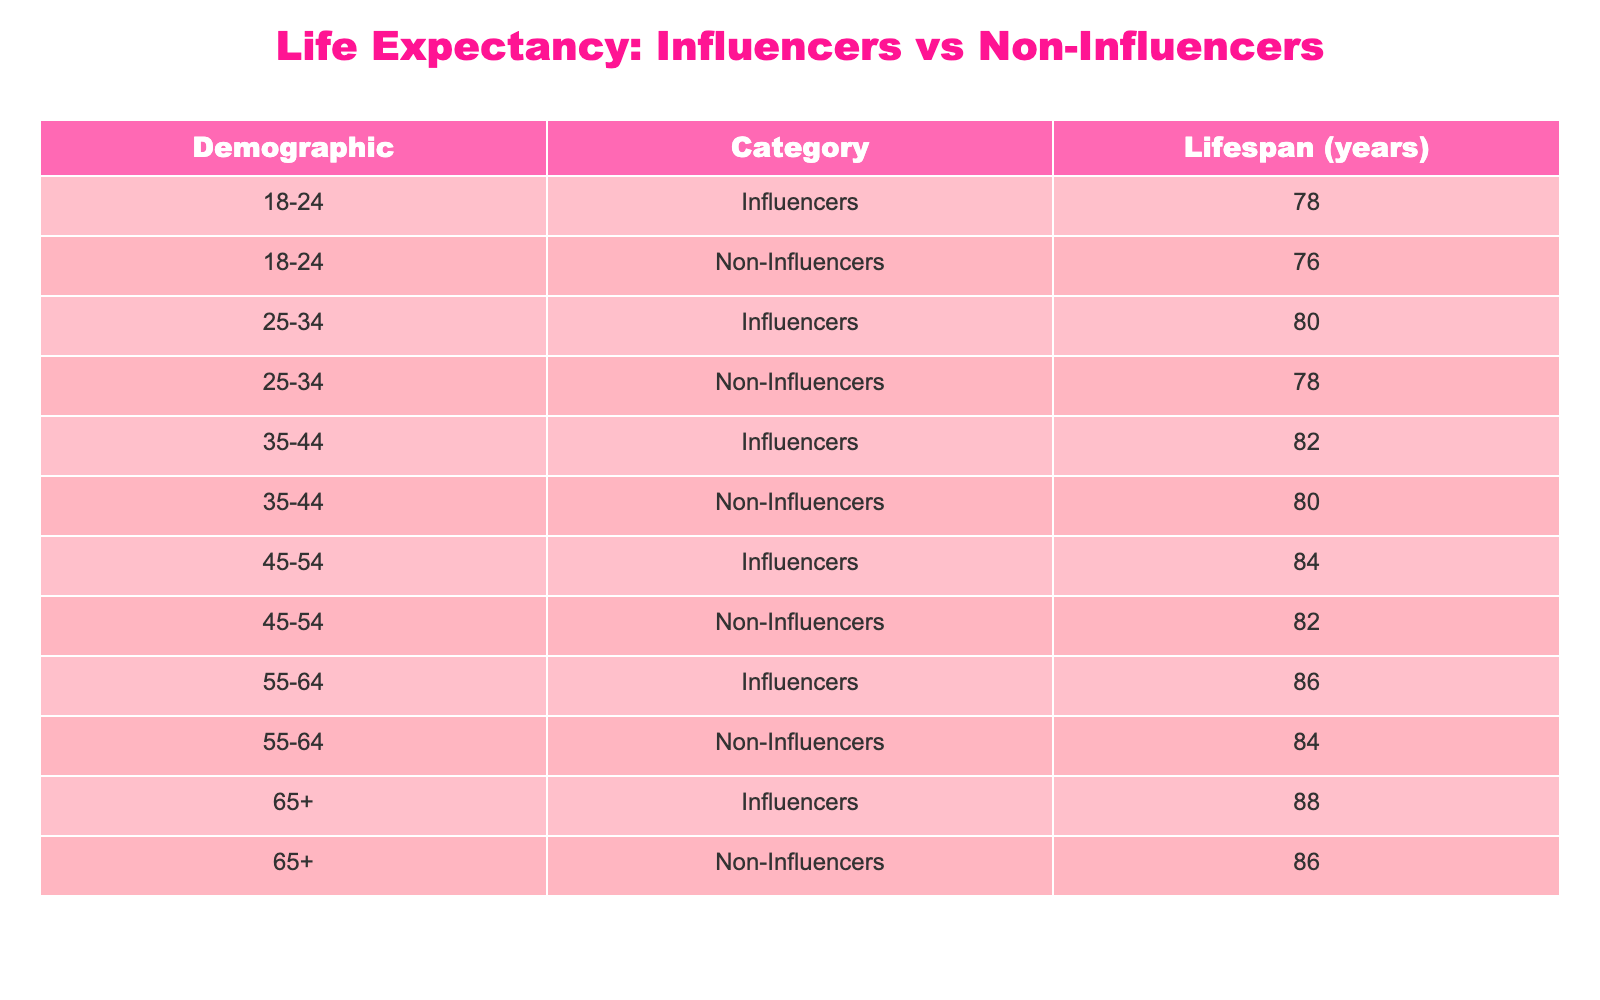What is the life expectancy of influencers aged 55-64? According to the table, the lifespan for influencers in the 55-64 demographic is listed explicitly. You can find the corresponding value from the row under "55-64" and "Influencers."
Answer: 86 What is the difference in life expectancy between non-influencers aged 25-34 and those aged 45-54? For non-influencers aged 25-34, the lifespan is 78 years, and for those aged 45-54, it is 82 years. The difference is calculated by subtracting the younger group's lifespan from the older group's lifespan: 82 - 78 = 4.
Answer: 4 Do influencers generally have a longer life expectancy than non-influencers across all demographics? By reviewing the table, influencers have a higher life expectancy than non-influencers in every listed age category, confirming that influencers generally have a longer lifespan.
Answer: Yes What is the average life expectancy of all influencers across the demographics? To calculate the average, sum the lifespans of influencers across all age groups: (78 + 80 + 82 + 84 + 86 + 88) = 498. Then divide by the number of age groups, which is 6: 498 / 6 = 83.
Answer: 83 Is the life expectancy of non-influencers in the 35-44 demographic higher than that of influencers in the 18-24 demographic? The life expectancy for non-influencers aged 35-44 is 80 years, while for influencers aged 18-24, it is 78 years. Since 80 is greater than 78, the statement is true.
Answer: Yes What is the life expectancy of non-influencers aged 65 and older? The lifespan of non-influencers in the 65+ category can be directly found in the corresponding row, which shows that it is 86 years.
Answer: 86 What is the total life expectancy for all non-influencer categories combined? The total lifespan for non-influencers is calculated by adding all the values: (76 + 78 + 80 + 82 + 84 + 86) = 486.
Answer: 486 Which demographic has the highest life expectancy among influencers? Reviewing the table, the 65+ demographic has the highest life expectancy for influencers at 88 years, making it the maximum lifespan among the influencers.
Answer: 88 